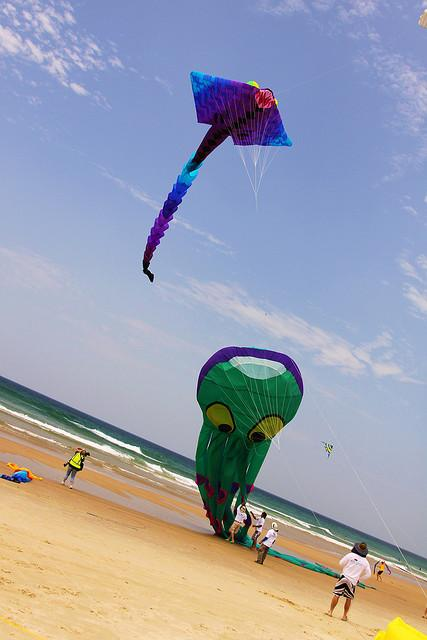How might the real version of the kite animal on top defend itself?

Choices:
A) hard shell
B) tusks
C) stinger
D) camouflage stinger 